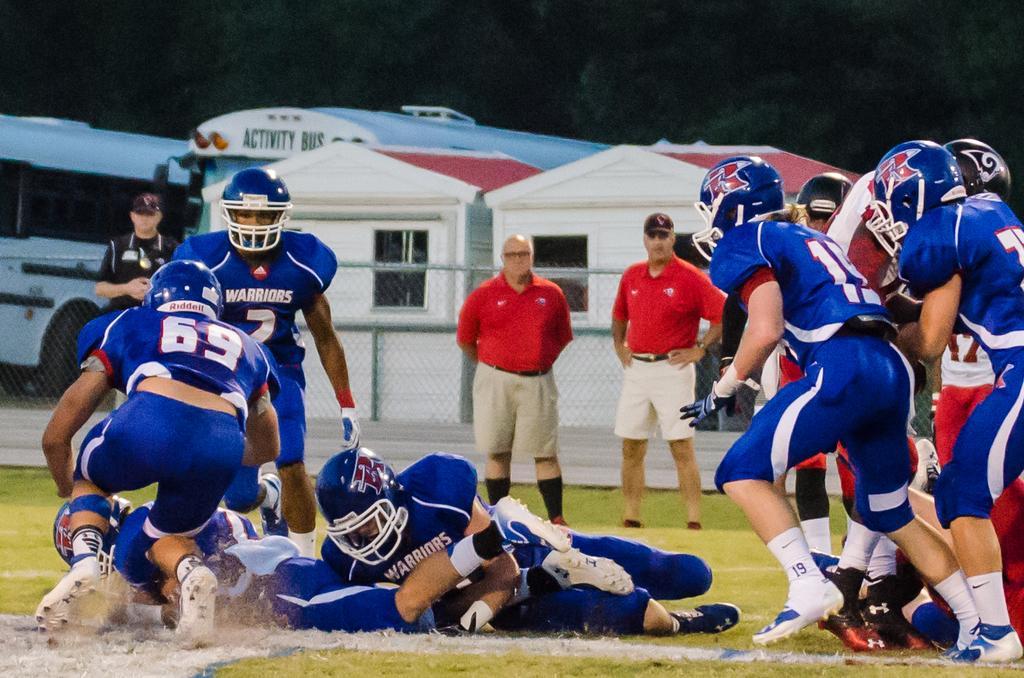Can you describe this image briefly? In this picture we can see a group of people on the ground and in the background we can see a fence,vehicles,sheds,trees. 